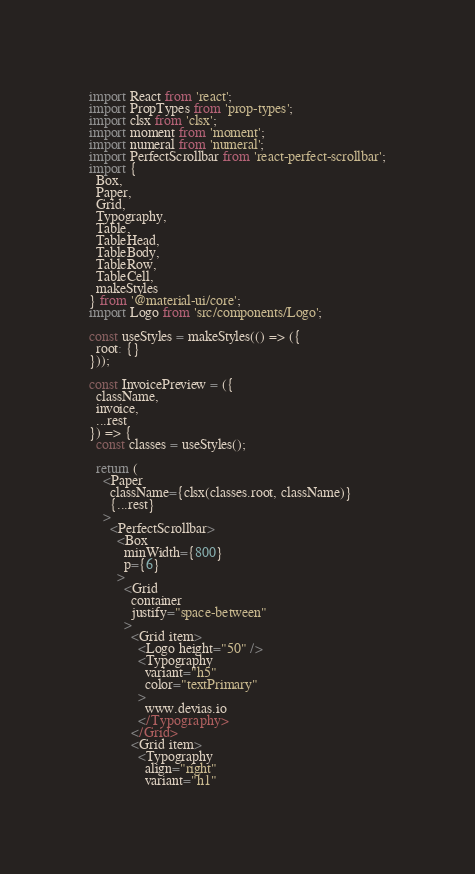<code> <loc_0><loc_0><loc_500><loc_500><_JavaScript_>import React from 'react';
import PropTypes from 'prop-types';
import clsx from 'clsx';
import moment from 'moment';
import numeral from 'numeral';
import PerfectScrollbar from 'react-perfect-scrollbar';
import {
  Box,
  Paper,
  Grid,
  Typography,
  Table,
  TableHead,
  TableBody,
  TableRow,
  TableCell,
  makeStyles
} from '@material-ui/core';
import Logo from 'src/components/Logo';

const useStyles = makeStyles(() => ({
  root: {}
}));

const InvoicePreview = ({ 
  className,
  invoice,
  ...rest
}) => {
  const classes = useStyles();

  return (
    <Paper
      className={clsx(classes.root, className)}
      {...rest}
    >
      <PerfectScrollbar>
        <Box
          minWidth={800}
          p={6}
        >
          <Grid
            container
            justify="space-between"
          >
            <Grid item>
              <Logo height="50" />
              <Typography
                variant="h5"
                color="textPrimary"
              >
                www.devias.io
              </Typography>
            </Grid>
            <Grid item>
              <Typography
                align="right"
                variant="h1"</code> 